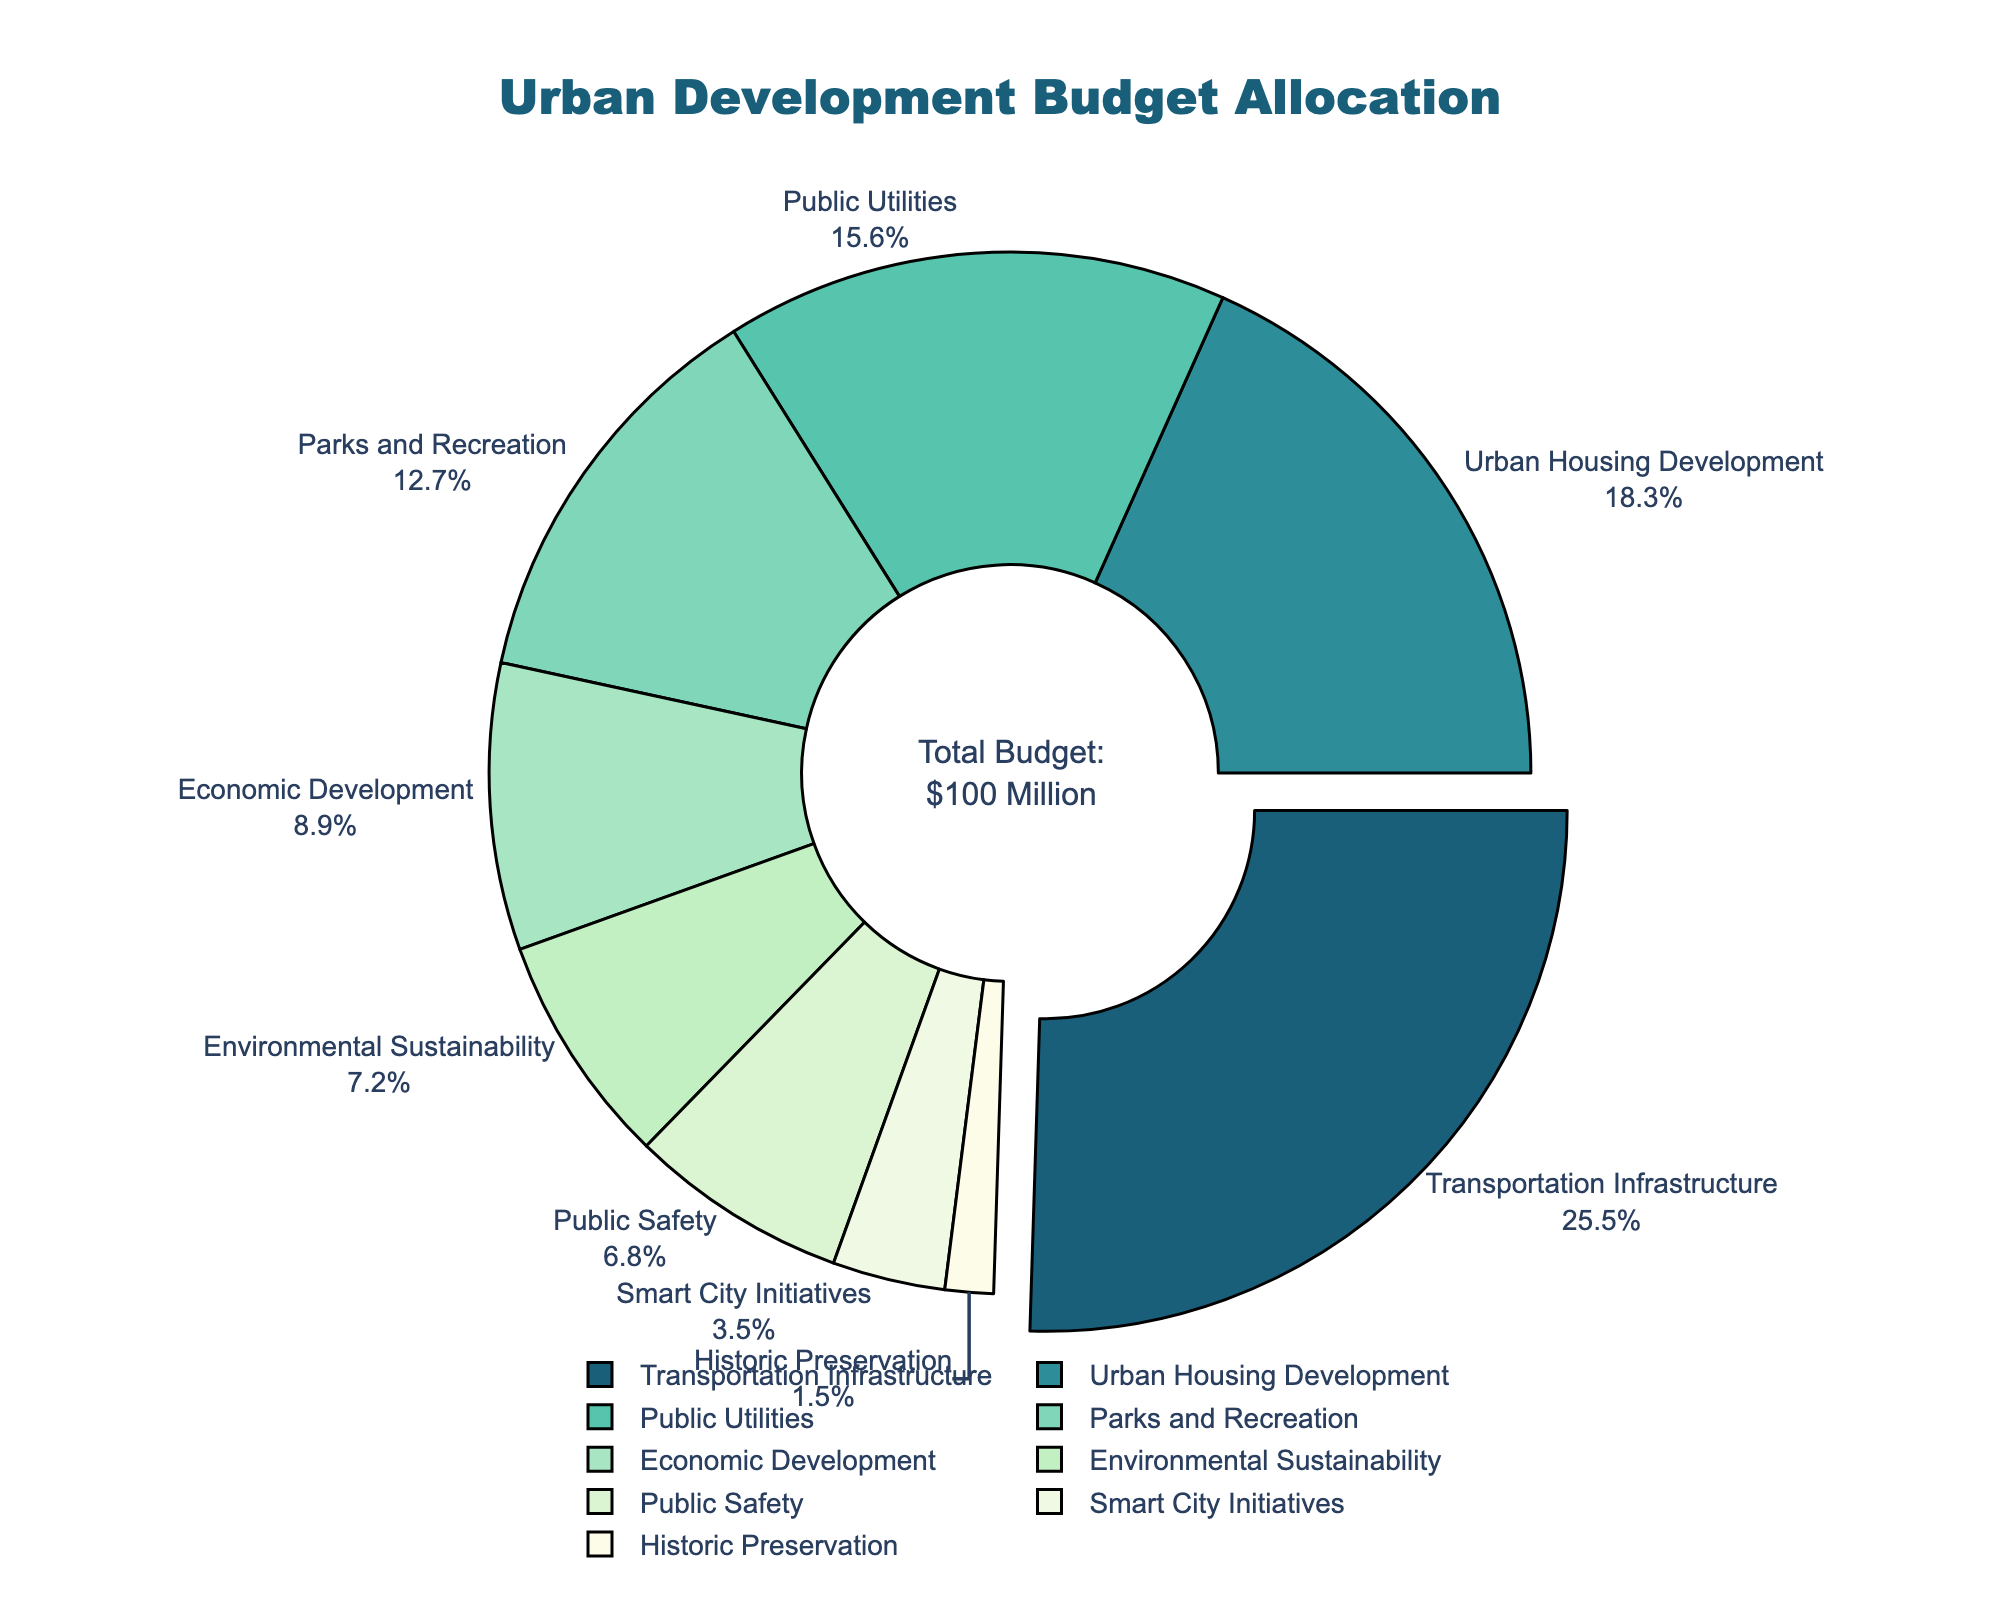What sector receives the highest budget allocation? The figure highlights the sector with the highest budget allocation by pulling its slice out slightly and showing the label and percentage. This sector is "Transportation Infrastructure," which receives the largest portion of the budget.
Answer: Transportation Infrastructure What is the combined budget allocation for Urban Housing Development and Parks and Recreation? To find the combined budget allocation, you need to sum the percentages of Urban Housing Development (18.3%) and Parks and Recreation (12.7%). The combined allocation is 18.3 + 12.7.
Answer: 31% Which sector has a higher budget allocation: Public Safety or Smart City Initiatives? The pie chart shows the budget allocation percentages for each sector. Public Safety has a budget allocation of 6.8%, whereas Smart City Initiatives has 3.5%. Since 6.8% is greater than 3.5%, Public Safety has a higher budget allocation.
Answer: Public Safety What's the difference in budget allocation between Economic Development and Environmental Sustainability? The budget allocation for Economic Development is 8.9% and for Environmental Sustainability is 7.2%. The difference is calculated by subtracting 7.2 from 8.9.
Answer: 1.7% Which sectors collectively make up less than 10% of the budget? Identifying sectors with allocations totaling less than 10% involves summing the individual percentages that fit this criteria. Here, only Historic Preservation at 1.5% and Smart City Initiatives at 3.5% add up to 5%, both individually less than 10%.
Answer: Historic Preservation and Smart City Initiatives What is the second-largest sector by budget allocation percentage? The legend and pie chart show the budget allocations in descending order. The second-largest segment is "Urban Housing Development," which receives 18.3% of the budget.
Answer: Urban Housing Development How much more is allocated to Parks and Recreation than to Public Safety? The budget allocations for Parks and Recreation (12.7%) and Public Safety (6.8%) are shown in the chart. The difference is calculated as 12.7 - 6.8.
Answer: 5.9% If we combine the budget allocations for Historic Preservation and Smart City Initiatives, what would their total allocation be? The budget allocations for Historic Preservation (1.5%) and Smart City Initiatives (3.5%) are demonstrated in the chart. Their total allocation is 1.5 + 3.5.
Answer: 5% Which segment is visually represented with the lightest color? By examining the color shades used in the pie chart, the lightest color corresponds to the segment representing the sector with the allocation of 1.5%, which is Historic Preservation.
Answer: Historic Preservation What is the budget allocation percentage for sectors related to utilities and infrastructure combined? To determine this, combine the budget percentages for "Transportation Infrastructure" (25.5%) and "Public Utilities" (15.6%). The total is 25.5 + 15.6.
Answer: 41.1% 